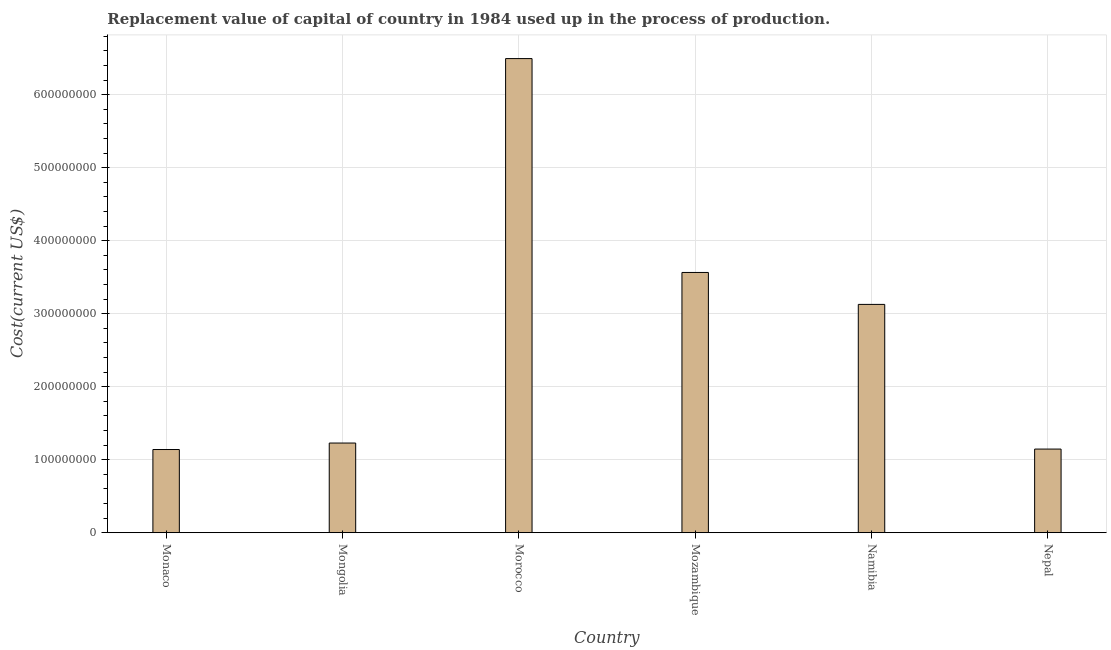Does the graph contain any zero values?
Your answer should be very brief. No. Does the graph contain grids?
Your response must be concise. Yes. What is the title of the graph?
Your answer should be very brief. Replacement value of capital of country in 1984 used up in the process of production. What is the label or title of the X-axis?
Provide a short and direct response. Country. What is the label or title of the Y-axis?
Make the answer very short. Cost(current US$). What is the consumption of fixed capital in Morocco?
Offer a very short reply. 6.49e+08. Across all countries, what is the maximum consumption of fixed capital?
Give a very brief answer. 6.49e+08. Across all countries, what is the minimum consumption of fixed capital?
Your answer should be very brief. 1.14e+08. In which country was the consumption of fixed capital maximum?
Keep it short and to the point. Morocco. In which country was the consumption of fixed capital minimum?
Provide a succinct answer. Monaco. What is the sum of the consumption of fixed capital?
Your answer should be compact. 1.67e+09. What is the difference between the consumption of fixed capital in Morocco and Nepal?
Your response must be concise. 5.35e+08. What is the average consumption of fixed capital per country?
Your answer should be compact. 2.78e+08. What is the median consumption of fixed capital?
Your response must be concise. 2.18e+08. In how many countries, is the consumption of fixed capital greater than 380000000 US$?
Give a very brief answer. 1. What is the ratio of the consumption of fixed capital in Monaco to that in Morocco?
Keep it short and to the point. 0.17. Is the consumption of fixed capital in Mozambique less than that in Namibia?
Offer a very short reply. No. What is the difference between the highest and the second highest consumption of fixed capital?
Offer a very short reply. 2.93e+08. Is the sum of the consumption of fixed capital in Monaco and Mozambique greater than the maximum consumption of fixed capital across all countries?
Provide a short and direct response. No. What is the difference between the highest and the lowest consumption of fixed capital?
Provide a short and direct response. 5.35e+08. How many bars are there?
Your answer should be compact. 6. What is the Cost(current US$) of Monaco?
Ensure brevity in your answer.  1.14e+08. What is the Cost(current US$) in Mongolia?
Provide a succinct answer. 1.23e+08. What is the Cost(current US$) in Morocco?
Offer a terse response. 6.49e+08. What is the Cost(current US$) of Mozambique?
Offer a very short reply. 3.56e+08. What is the Cost(current US$) in Namibia?
Offer a very short reply. 3.13e+08. What is the Cost(current US$) of Nepal?
Make the answer very short. 1.15e+08. What is the difference between the Cost(current US$) in Monaco and Mongolia?
Ensure brevity in your answer.  -8.86e+06. What is the difference between the Cost(current US$) in Monaco and Morocco?
Offer a very short reply. -5.35e+08. What is the difference between the Cost(current US$) in Monaco and Mozambique?
Your answer should be very brief. -2.42e+08. What is the difference between the Cost(current US$) in Monaco and Namibia?
Make the answer very short. -1.99e+08. What is the difference between the Cost(current US$) in Monaco and Nepal?
Provide a short and direct response. -6.06e+05. What is the difference between the Cost(current US$) in Mongolia and Morocco?
Give a very brief answer. -5.27e+08. What is the difference between the Cost(current US$) in Mongolia and Mozambique?
Your answer should be very brief. -2.34e+08. What is the difference between the Cost(current US$) in Mongolia and Namibia?
Ensure brevity in your answer.  -1.90e+08. What is the difference between the Cost(current US$) in Mongolia and Nepal?
Your response must be concise. 8.26e+06. What is the difference between the Cost(current US$) in Morocco and Mozambique?
Make the answer very short. 2.93e+08. What is the difference between the Cost(current US$) in Morocco and Namibia?
Offer a very short reply. 3.37e+08. What is the difference between the Cost(current US$) in Morocco and Nepal?
Make the answer very short. 5.35e+08. What is the difference between the Cost(current US$) in Mozambique and Namibia?
Give a very brief answer. 4.37e+07. What is the difference between the Cost(current US$) in Mozambique and Nepal?
Ensure brevity in your answer.  2.42e+08. What is the difference between the Cost(current US$) in Namibia and Nepal?
Provide a short and direct response. 1.98e+08. What is the ratio of the Cost(current US$) in Monaco to that in Mongolia?
Offer a terse response. 0.93. What is the ratio of the Cost(current US$) in Monaco to that in Morocco?
Ensure brevity in your answer.  0.17. What is the ratio of the Cost(current US$) in Monaco to that in Mozambique?
Provide a succinct answer. 0.32. What is the ratio of the Cost(current US$) in Monaco to that in Namibia?
Ensure brevity in your answer.  0.36. What is the ratio of the Cost(current US$) in Mongolia to that in Morocco?
Your response must be concise. 0.19. What is the ratio of the Cost(current US$) in Mongolia to that in Mozambique?
Provide a succinct answer. 0.34. What is the ratio of the Cost(current US$) in Mongolia to that in Namibia?
Keep it short and to the point. 0.39. What is the ratio of the Cost(current US$) in Mongolia to that in Nepal?
Ensure brevity in your answer.  1.07. What is the ratio of the Cost(current US$) in Morocco to that in Mozambique?
Offer a very short reply. 1.82. What is the ratio of the Cost(current US$) in Morocco to that in Namibia?
Provide a short and direct response. 2.08. What is the ratio of the Cost(current US$) in Morocco to that in Nepal?
Provide a succinct answer. 5.67. What is the ratio of the Cost(current US$) in Mozambique to that in Namibia?
Your answer should be compact. 1.14. What is the ratio of the Cost(current US$) in Mozambique to that in Nepal?
Provide a short and direct response. 3.11. What is the ratio of the Cost(current US$) in Namibia to that in Nepal?
Provide a succinct answer. 2.73. 